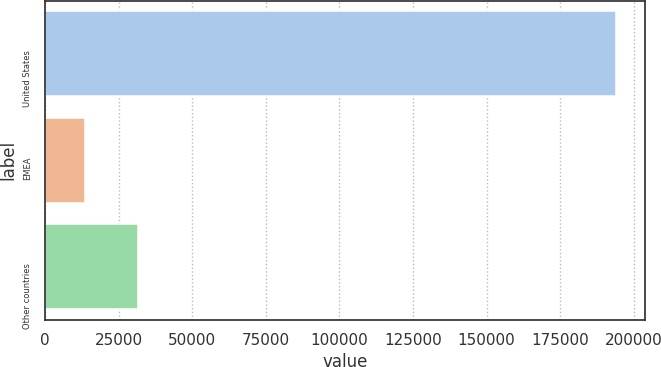Convert chart. <chart><loc_0><loc_0><loc_500><loc_500><bar_chart><fcel>United States<fcel>EMEA<fcel>Other countries<nl><fcel>194176<fcel>13451<fcel>31523.5<nl></chart> 